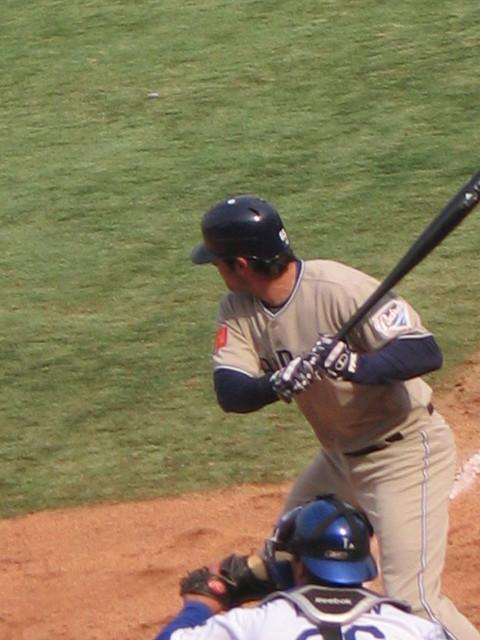Which hand is dominant in the batter shown? Please explain your reasoning. left. He is swinging back on his left side, meaning the let hand is dominant 